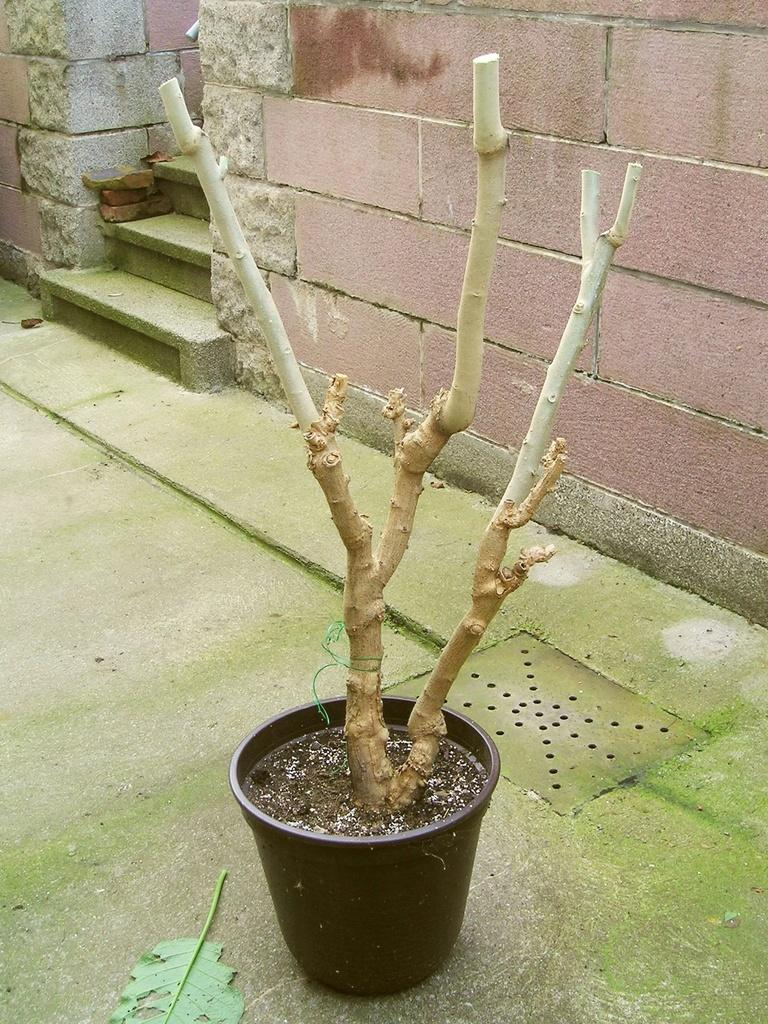What type of plant is in the pot in the image? There is a dry plant in a pot in the image. What can be observed about the plant's appearance? The plant has only stems and branches. What can be seen in the background of the image? There is a brick wall in the background of the image. Are there any architectural features visible in the image? Yes, there are stairs between the brick wall in the background. How does the friend help the plant grow in the image? There is no friend present in the image, and the plant is already dry and not growing. What type of muscle can be seen flexing in the image? There are no muscles visible in the image; it features a dry plant in a pot and a brick wall with stairs in the background. 